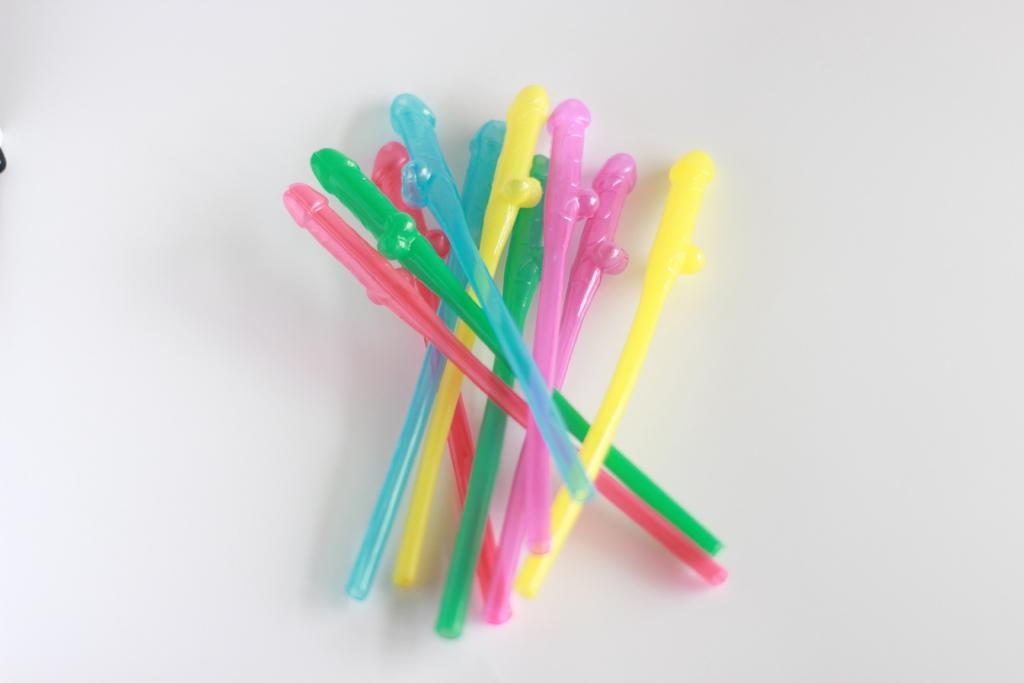What objects are present in the image? There are colorful sticks in the image. What is the colorful sticks placed on? The colorful sticks are placed on a white surface. What is the rate of increase in the number of hearts in the image? There are no hearts present in the image, so it is not possible to determine a rate of increase. 